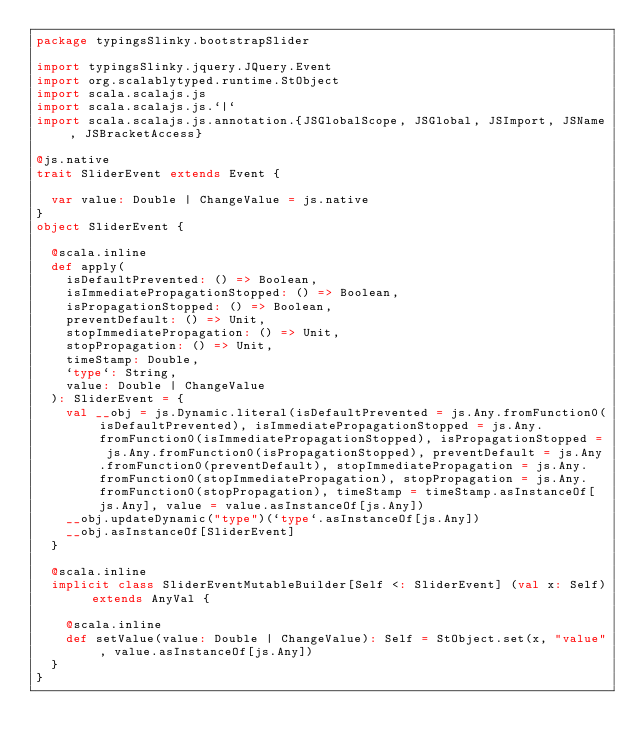Convert code to text. <code><loc_0><loc_0><loc_500><loc_500><_Scala_>package typingsSlinky.bootstrapSlider

import typingsSlinky.jquery.JQuery.Event
import org.scalablytyped.runtime.StObject
import scala.scalajs.js
import scala.scalajs.js.`|`
import scala.scalajs.js.annotation.{JSGlobalScope, JSGlobal, JSImport, JSName, JSBracketAccess}

@js.native
trait SliderEvent extends Event {
  
  var value: Double | ChangeValue = js.native
}
object SliderEvent {
  
  @scala.inline
  def apply(
    isDefaultPrevented: () => Boolean,
    isImmediatePropagationStopped: () => Boolean,
    isPropagationStopped: () => Boolean,
    preventDefault: () => Unit,
    stopImmediatePropagation: () => Unit,
    stopPropagation: () => Unit,
    timeStamp: Double,
    `type`: String,
    value: Double | ChangeValue
  ): SliderEvent = {
    val __obj = js.Dynamic.literal(isDefaultPrevented = js.Any.fromFunction0(isDefaultPrevented), isImmediatePropagationStopped = js.Any.fromFunction0(isImmediatePropagationStopped), isPropagationStopped = js.Any.fromFunction0(isPropagationStopped), preventDefault = js.Any.fromFunction0(preventDefault), stopImmediatePropagation = js.Any.fromFunction0(stopImmediatePropagation), stopPropagation = js.Any.fromFunction0(stopPropagation), timeStamp = timeStamp.asInstanceOf[js.Any], value = value.asInstanceOf[js.Any])
    __obj.updateDynamic("type")(`type`.asInstanceOf[js.Any])
    __obj.asInstanceOf[SliderEvent]
  }
  
  @scala.inline
  implicit class SliderEventMutableBuilder[Self <: SliderEvent] (val x: Self) extends AnyVal {
    
    @scala.inline
    def setValue(value: Double | ChangeValue): Self = StObject.set(x, "value", value.asInstanceOf[js.Any])
  }
}
</code> 